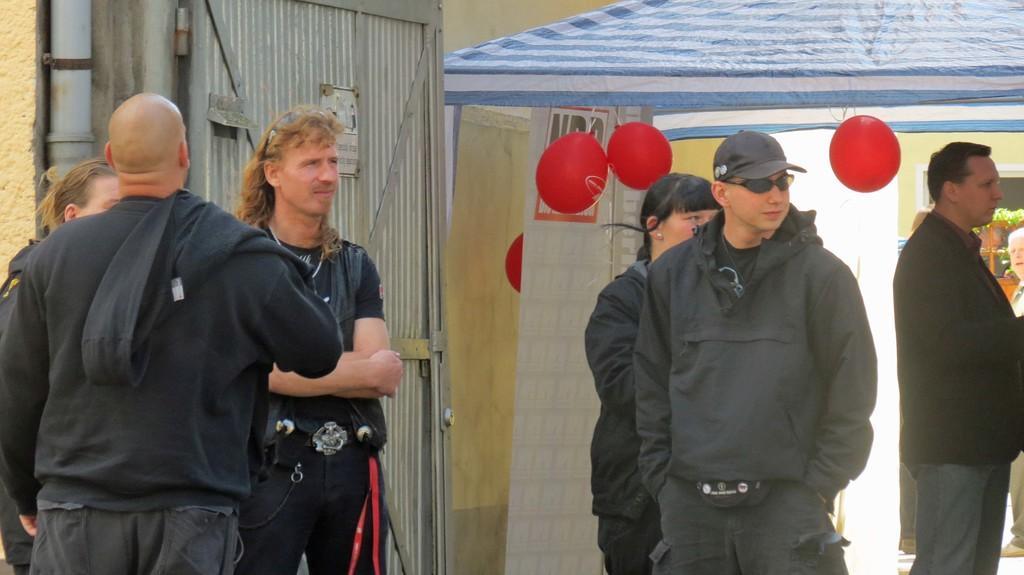How would you summarize this image in a sentence or two? In this image a person wearing a black jacket is having goggles and cap. Behind him there is a woman. Behind him there is a tent having few balloons tied to it. Right side there is a person wearing a suit. Behind him there are few persons and few pots having plants in it. Left side there is a metal gate. Before it there are few persons standing. 